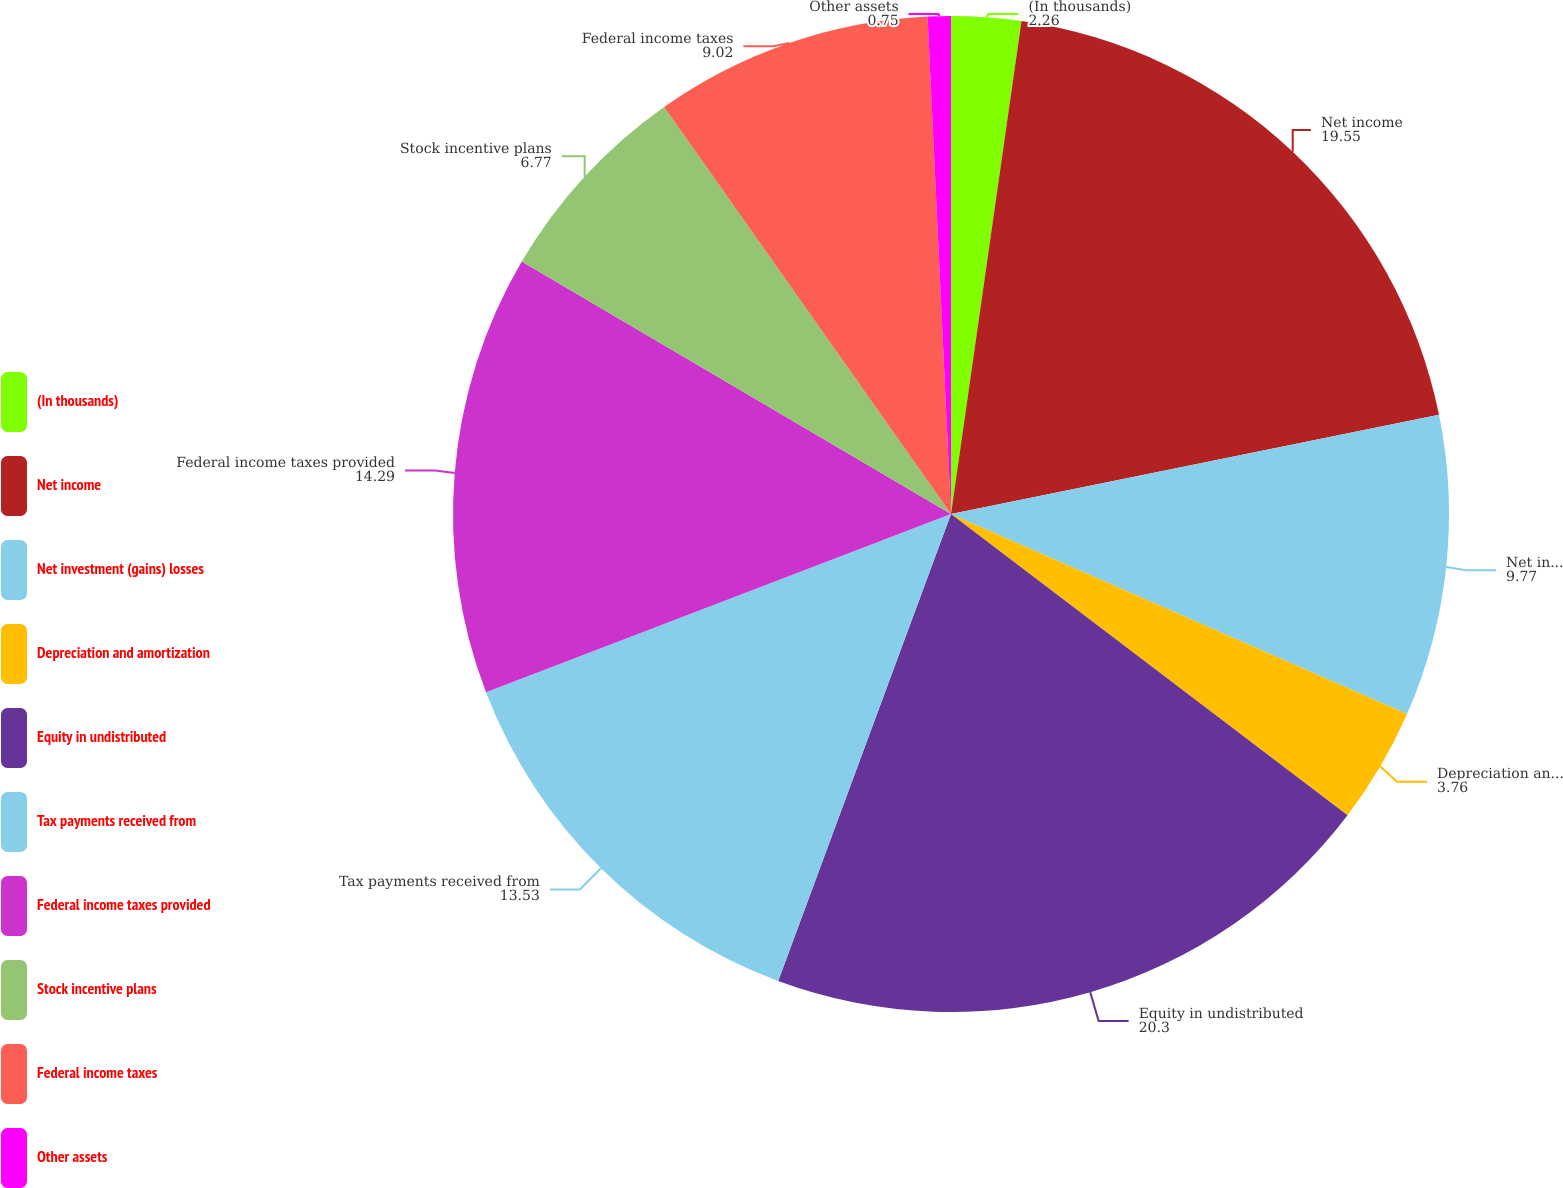<chart> <loc_0><loc_0><loc_500><loc_500><pie_chart><fcel>(In thousands)<fcel>Net income<fcel>Net investment (gains) losses<fcel>Depreciation and amortization<fcel>Equity in undistributed<fcel>Tax payments received from<fcel>Federal income taxes provided<fcel>Stock incentive plans<fcel>Federal income taxes<fcel>Other assets<nl><fcel>2.26%<fcel>19.55%<fcel>9.77%<fcel>3.76%<fcel>20.3%<fcel>13.53%<fcel>14.29%<fcel>6.77%<fcel>9.02%<fcel>0.75%<nl></chart> 